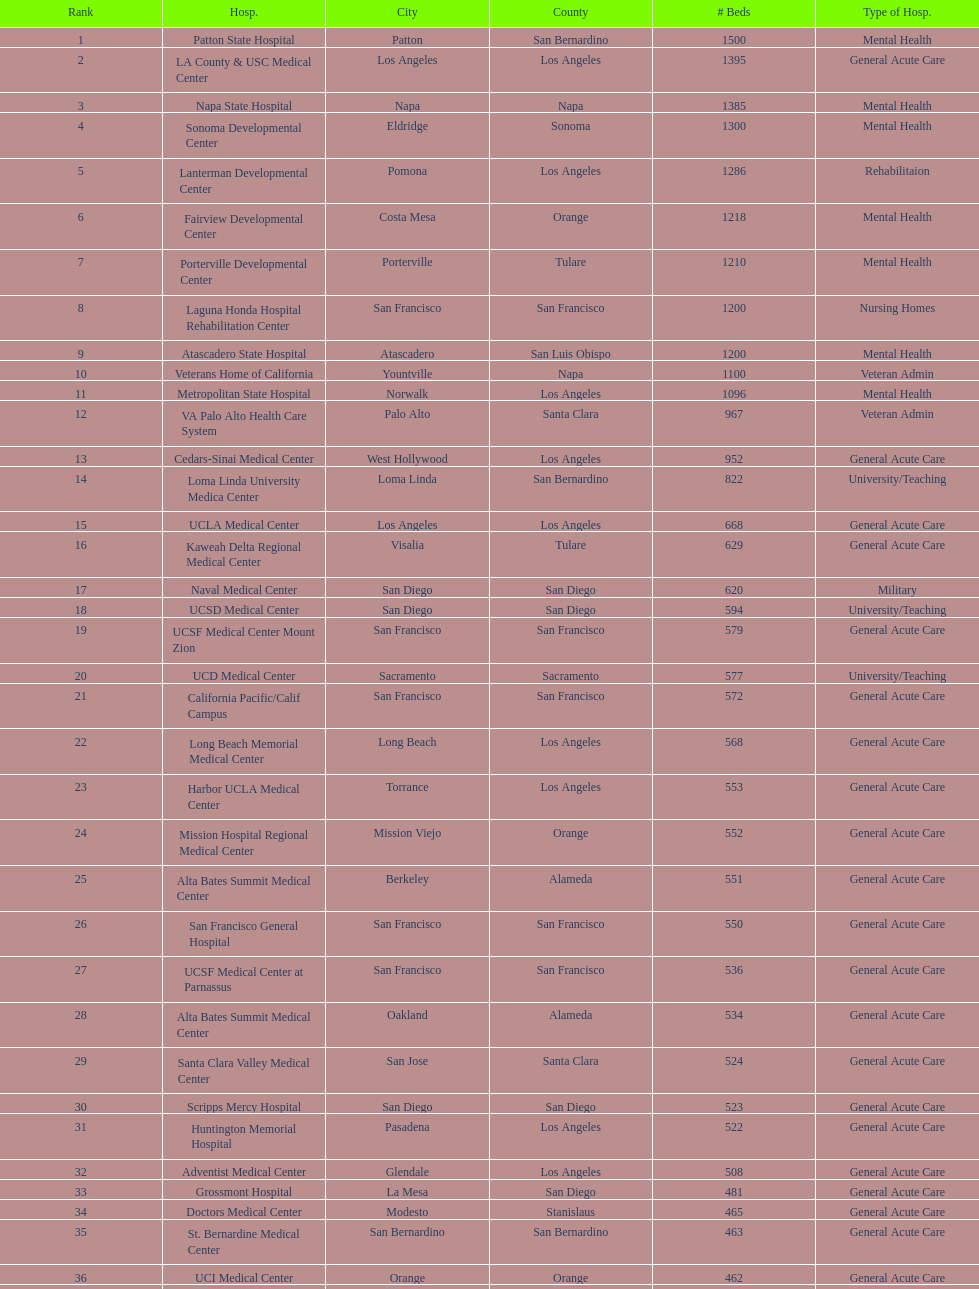How many hospital's have at least 600 beds? 17. Parse the full table. {'header': ['Rank', 'Hosp.', 'City', 'County', '# Beds', 'Type of Hosp.'], 'rows': [['1', 'Patton State Hospital', 'Patton', 'San Bernardino', '1500', 'Mental Health'], ['2', 'LA County & USC Medical Center', 'Los Angeles', 'Los Angeles', '1395', 'General Acute Care'], ['3', 'Napa State Hospital', 'Napa', 'Napa', '1385', 'Mental Health'], ['4', 'Sonoma Developmental Center', 'Eldridge', 'Sonoma', '1300', 'Mental Health'], ['5', 'Lanterman Developmental Center', 'Pomona', 'Los Angeles', '1286', 'Rehabilitaion'], ['6', 'Fairview Developmental Center', 'Costa Mesa', 'Orange', '1218', 'Mental Health'], ['7', 'Porterville Developmental Center', 'Porterville', 'Tulare', '1210', 'Mental Health'], ['8', 'Laguna Honda Hospital Rehabilitation Center', 'San Francisco', 'San Francisco', '1200', 'Nursing Homes'], ['9', 'Atascadero State Hospital', 'Atascadero', 'San Luis Obispo', '1200', 'Mental Health'], ['10', 'Veterans Home of California', 'Yountville', 'Napa', '1100', 'Veteran Admin'], ['11', 'Metropolitan State Hospital', 'Norwalk', 'Los Angeles', '1096', 'Mental Health'], ['12', 'VA Palo Alto Health Care System', 'Palo Alto', 'Santa Clara', '967', 'Veteran Admin'], ['13', 'Cedars-Sinai Medical Center', 'West Hollywood', 'Los Angeles', '952', 'General Acute Care'], ['14', 'Loma Linda University Medica Center', 'Loma Linda', 'San Bernardino', '822', 'University/Teaching'], ['15', 'UCLA Medical Center', 'Los Angeles', 'Los Angeles', '668', 'General Acute Care'], ['16', 'Kaweah Delta Regional Medical Center', 'Visalia', 'Tulare', '629', 'General Acute Care'], ['17', 'Naval Medical Center', 'San Diego', 'San Diego', '620', 'Military'], ['18', 'UCSD Medical Center', 'San Diego', 'San Diego', '594', 'University/Teaching'], ['19', 'UCSF Medical Center Mount Zion', 'San Francisco', 'San Francisco', '579', 'General Acute Care'], ['20', 'UCD Medical Center', 'Sacramento', 'Sacramento', '577', 'University/Teaching'], ['21', 'California Pacific/Calif Campus', 'San Francisco', 'San Francisco', '572', 'General Acute Care'], ['22', 'Long Beach Memorial Medical Center', 'Long Beach', 'Los Angeles', '568', 'General Acute Care'], ['23', 'Harbor UCLA Medical Center', 'Torrance', 'Los Angeles', '553', 'General Acute Care'], ['24', 'Mission Hospital Regional Medical Center', 'Mission Viejo', 'Orange', '552', 'General Acute Care'], ['25', 'Alta Bates Summit Medical Center', 'Berkeley', 'Alameda', '551', 'General Acute Care'], ['26', 'San Francisco General Hospital', 'San Francisco', 'San Francisco', '550', 'General Acute Care'], ['27', 'UCSF Medical Center at Parnassus', 'San Francisco', 'San Francisco', '536', 'General Acute Care'], ['28', 'Alta Bates Summit Medical Center', 'Oakland', 'Alameda', '534', 'General Acute Care'], ['29', 'Santa Clara Valley Medical Center', 'San Jose', 'Santa Clara', '524', 'General Acute Care'], ['30', 'Scripps Mercy Hospital', 'San Diego', 'San Diego', '523', 'General Acute Care'], ['31', 'Huntington Memorial Hospital', 'Pasadena', 'Los Angeles', '522', 'General Acute Care'], ['32', 'Adventist Medical Center', 'Glendale', 'Los Angeles', '508', 'General Acute Care'], ['33', 'Grossmont Hospital', 'La Mesa', 'San Diego', '481', 'General Acute Care'], ['34', 'Doctors Medical Center', 'Modesto', 'Stanislaus', '465', 'General Acute Care'], ['35', 'St. Bernardine Medical Center', 'San Bernardino', 'San Bernardino', '463', 'General Acute Care'], ['36', 'UCI Medical Center', 'Orange', 'Orange', '462', 'General Acute Care'], ['37', 'Stanford Medical Center', 'Stanford', 'Santa Clara', '460', 'General Acute Care'], ['38', 'Community Regional Medical Center', 'Fresno', 'Fresno', '457', 'General Acute Care'], ['39', 'Methodist Hospital', 'Arcadia', 'Los Angeles', '455', 'General Acute Care'], ['40', 'Providence St. Joseph Medical Center', 'Burbank', 'Los Angeles', '455', 'General Acute Care'], ['41', 'Hoag Memorial Hospital', 'Newport Beach', 'Orange', '450', 'General Acute Care'], ['42', 'Agnews Developmental Center', 'San Jose', 'Santa Clara', '450', 'Mental Health'], ['43', 'Jewish Home', 'San Francisco', 'San Francisco', '450', 'Nursing Homes'], ['44', 'St. Joseph Hospital Orange', 'Orange', 'Orange', '448', 'General Acute Care'], ['45', 'Presbyterian Intercommunity', 'Whittier', 'Los Angeles', '441', 'General Acute Care'], ['46', 'Kaiser Permanente Medical Center', 'Fontana', 'San Bernardino', '440', 'General Acute Care'], ['47', 'Kaiser Permanente Medical Center', 'Los Angeles', 'Los Angeles', '439', 'General Acute Care'], ['48', 'Pomona Valley Hospital Medical Center', 'Pomona', 'Los Angeles', '436', 'General Acute Care'], ['49', 'Sutter General Medical Center', 'Sacramento', 'Sacramento', '432', 'General Acute Care'], ['50', 'St. Mary Medical Center', 'San Francisco', 'San Francisco', '430', 'General Acute Care'], ['50', 'Good Samaritan Hospital', 'San Jose', 'Santa Clara', '429', 'General Acute Care']]} 